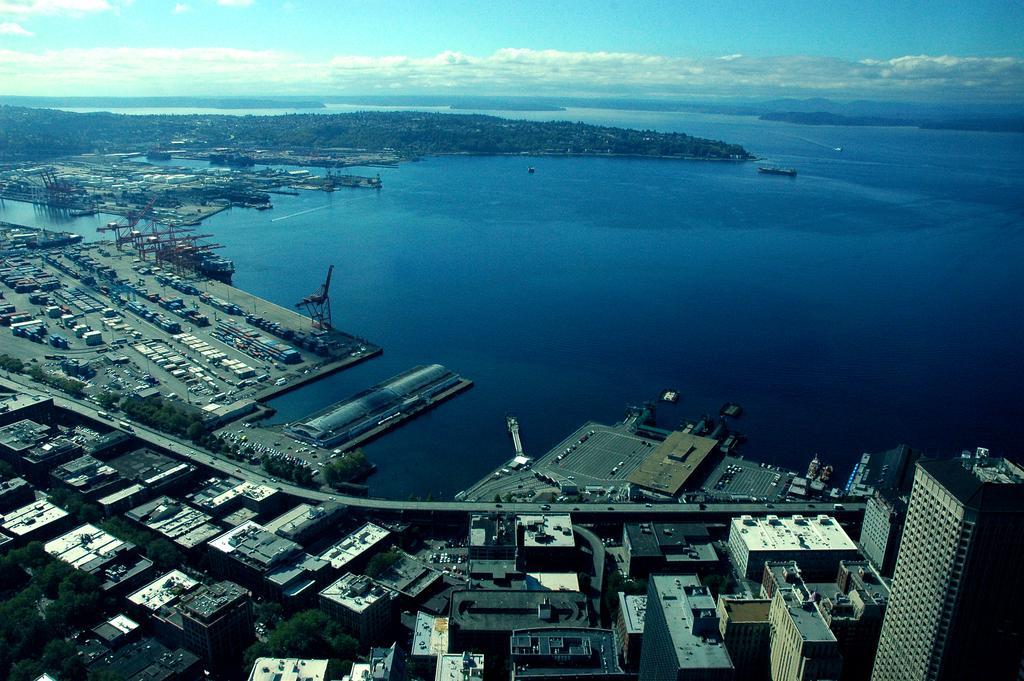How would you summarize this image in a sentence or two? This is a top angle of an image. In this image there are so many buildings, vehicles, river, trees and the sky. 